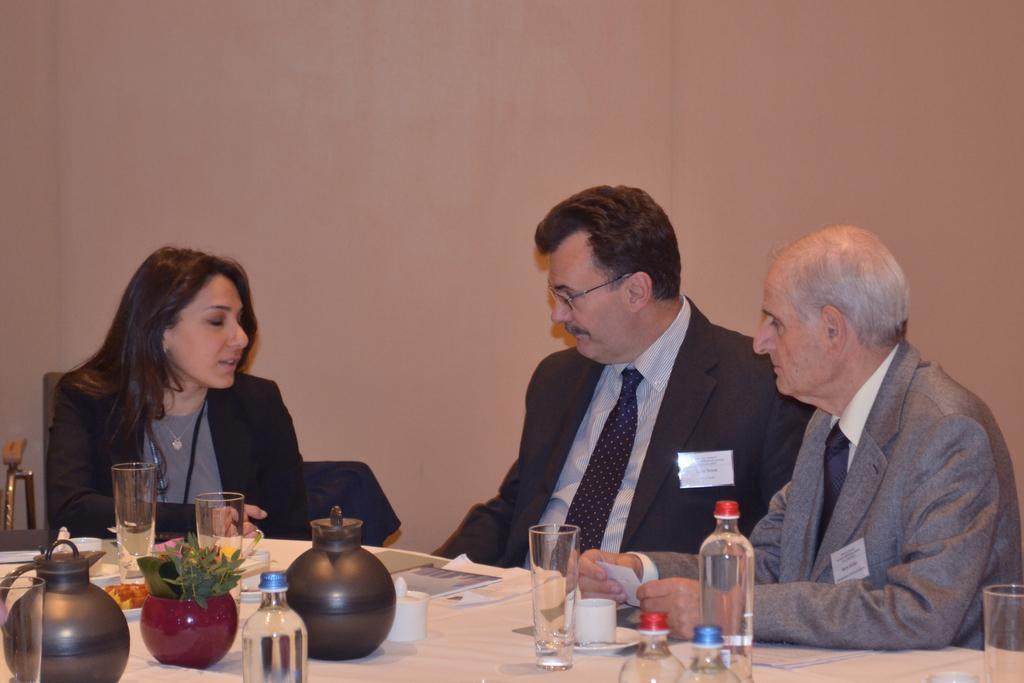Describe this image in one or two sentences. In the image there is a woman and two men sat on chair around the table. It had water bottles,jars and bowls on it. 